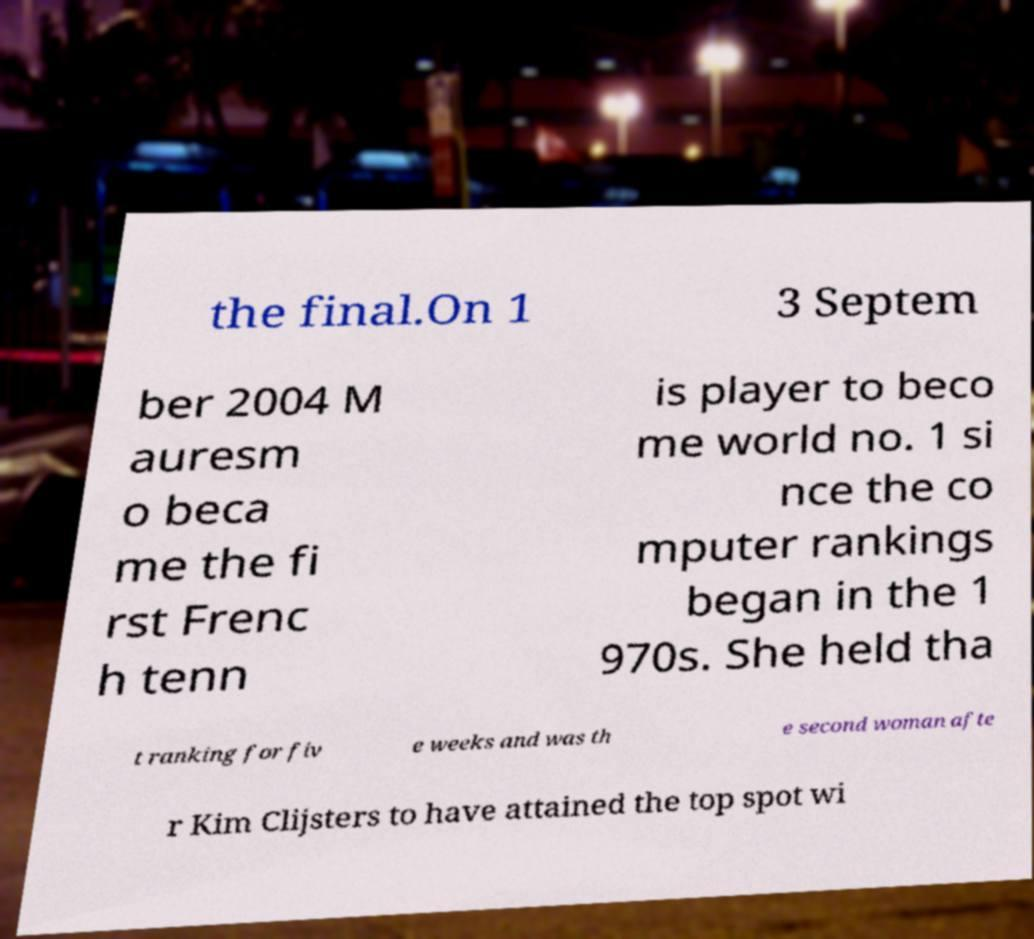There's text embedded in this image that I need extracted. Can you transcribe it verbatim? the final.On 1 3 Septem ber 2004 M auresm o beca me the fi rst Frenc h tenn is player to beco me world no. 1 si nce the co mputer rankings began in the 1 970s. She held tha t ranking for fiv e weeks and was th e second woman afte r Kim Clijsters to have attained the top spot wi 